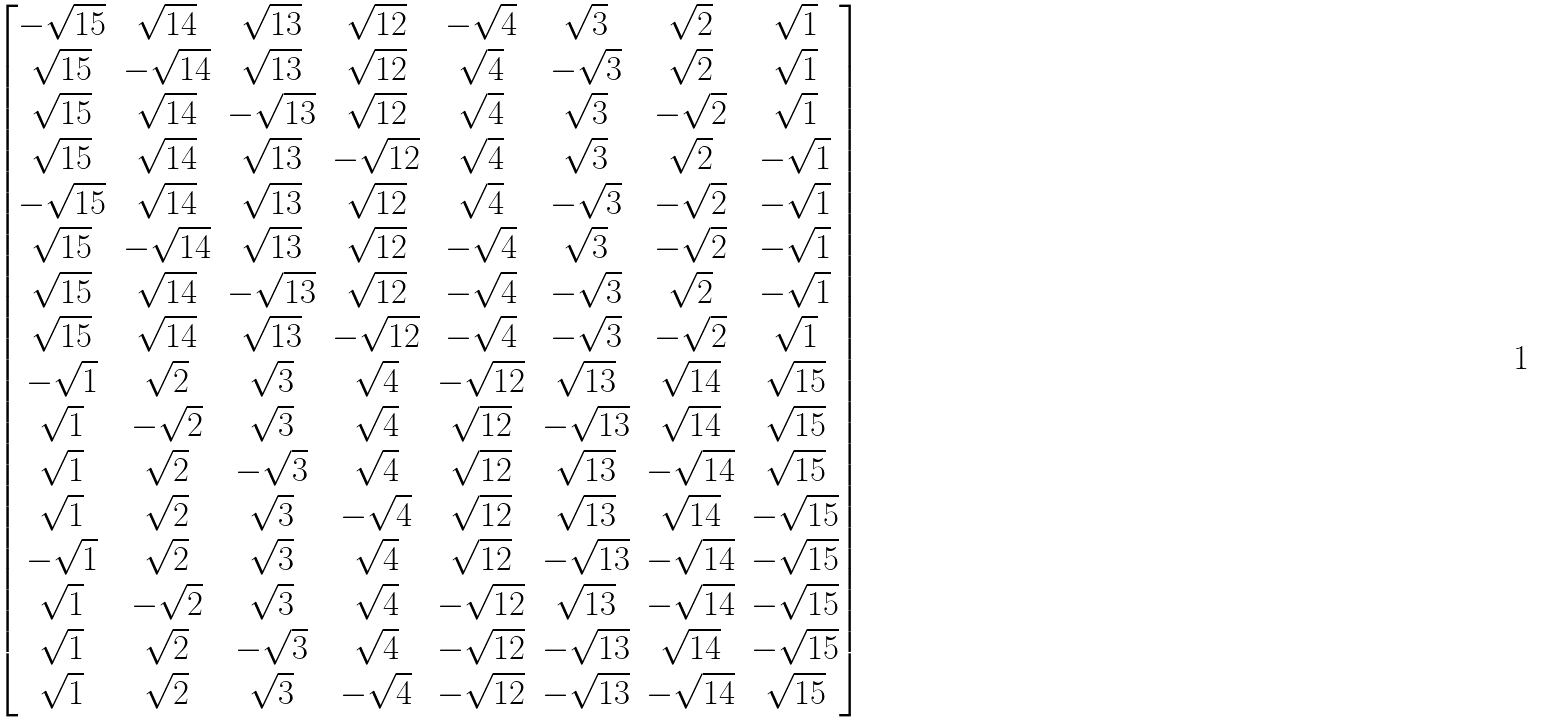<formula> <loc_0><loc_0><loc_500><loc_500>\begin{bmatrix} - \sqrt { 1 5 } & \sqrt { 1 4 } & \sqrt { 1 3 } & \sqrt { 1 2 } & - \sqrt { 4 } & \sqrt { 3 } & \sqrt { 2 } & \sqrt { 1 } \\ \sqrt { 1 5 } & - \sqrt { 1 4 } & \sqrt { 1 3 } & \sqrt { 1 2 } & \sqrt { 4 } & - \sqrt { 3 } & \sqrt { 2 } & \sqrt { 1 } \\ \sqrt { 1 5 } & \sqrt { 1 4 } & - \sqrt { 1 3 } & \sqrt { 1 2 } & \sqrt { 4 } & \sqrt { 3 } & - \sqrt { 2 } & \sqrt { 1 } \\ \sqrt { 1 5 } & \sqrt { 1 4 } & \sqrt { 1 3 } & - \sqrt { 1 2 } & \sqrt { 4 } & \sqrt { 3 } & \sqrt { 2 } & - \sqrt { 1 } \\ - \sqrt { 1 5 } & \sqrt { 1 4 } & \sqrt { 1 3 } & \sqrt { 1 2 } & \sqrt { 4 } & - \sqrt { 3 } & - \sqrt { 2 } & - \sqrt { 1 } \\ \sqrt { 1 5 } & - \sqrt { 1 4 } & \sqrt { 1 3 } & \sqrt { 1 2 } & - \sqrt { 4 } & \sqrt { 3 } & - \sqrt { 2 } & - \sqrt { 1 } \\ \sqrt { 1 5 } & \sqrt { 1 4 } & - \sqrt { 1 3 } & \sqrt { 1 2 } & - \sqrt { 4 } & - \sqrt { 3 } & \sqrt { 2 } & - \sqrt { 1 } \\ \sqrt { 1 5 } & \sqrt { 1 4 } & \sqrt { 1 3 } & - \sqrt { 1 2 } & - \sqrt { 4 } & - \sqrt { 3 } & - \sqrt { 2 } & \sqrt { 1 } \\ - \sqrt { 1 } & \sqrt { 2 } & \sqrt { 3 } & \sqrt { 4 } & - \sqrt { 1 2 } & \sqrt { 1 3 } & \sqrt { 1 4 } & \sqrt { 1 5 } \\ \sqrt { 1 } & - \sqrt { 2 } & \sqrt { 3 } & \sqrt { 4 } & \sqrt { 1 2 } & - \sqrt { 1 3 } & \sqrt { 1 4 } & \sqrt { 1 5 } \\ \sqrt { 1 } & \sqrt { 2 } & - \sqrt { 3 } & \sqrt { 4 } & \sqrt { 1 2 } & \sqrt { 1 3 } & - \sqrt { 1 4 } & \sqrt { 1 5 } \\ \sqrt { 1 } & \sqrt { 2 } & \sqrt { 3 } & - \sqrt { 4 } & \sqrt { 1 2 } & \sqrt { 1 3 } & \sqrt { 1 4 } & - \sqrt { 1 5 } \\ - \sqrt { 1 } & \sqrt { 2 } & \sqrt { 3 } & \sqrt { 4 } & \sqrt { 1 2 } & - \sqrt { 1 3 } & - \sqrt { 1 4 } & - \sqrt { 1 5 } \\ \sqrt { 1 } & - \sqrt { 2 } & \sqrt { 3 } & \sqrt { 4 } & - \sqrt { 1 2 } & \sqrt { 1 3 } & - \sqrt { 1 4 } & - \sqrt { 1 5 } \\ \sqrt { 1 } & \sqrt { 2 } & - \sqrt { 3 } & \sqrt { 4 } & - \sqrt { 1 2 } & - \sqrt { 1 3 } & \sqrt { 1 4 } & - \sqrt { 1 5 } \\ \sqrt { 1 } & \sqrt { 2 } & \sqrt { 3 } & - \sqrt { 4 } & - \sqrt { 1 2 } & - \sqrt { 1 3 } & - \sqrt { 1 4 } & \sqrt { 1 5 } \\ \end{bmatrix}</formula> 